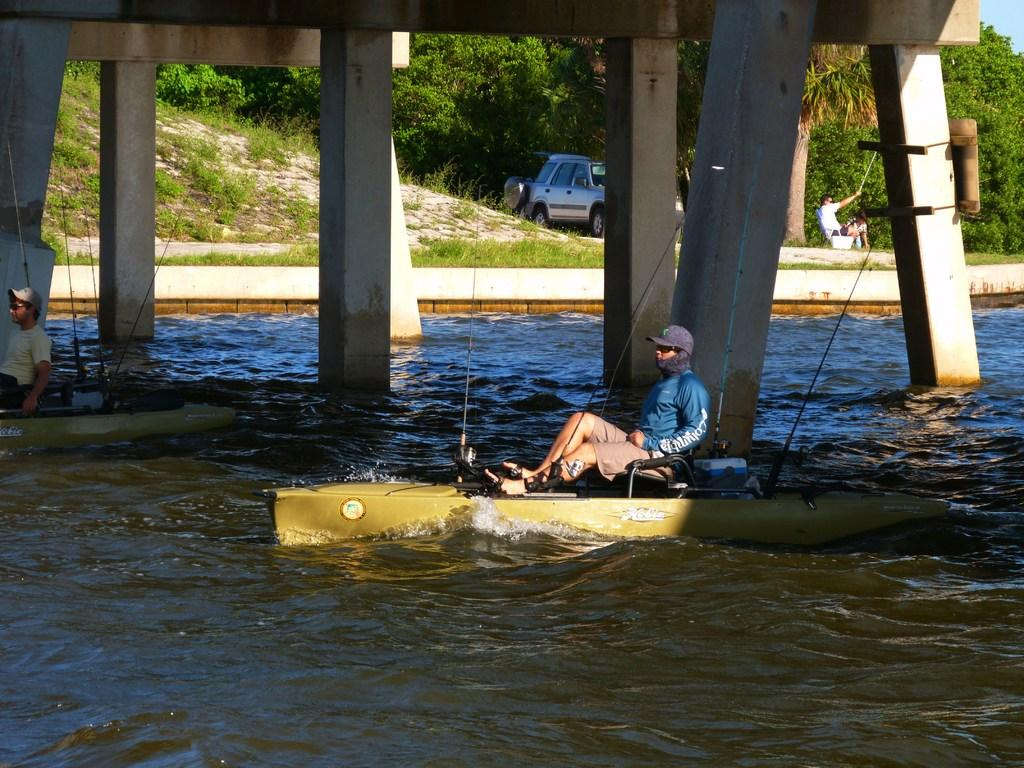How many people are in the image? There are two persons in the image. What are the persons doing in the image? The persons are sailing boats on the water. What can be seen in the background of the image? There are pillars, plants, a vehicle, people, and trees in the background of the image. What type of furniture can be seen in the image? There is no furniture present in the image. How many snails are visible in the image? There are no snails visible in the image. 